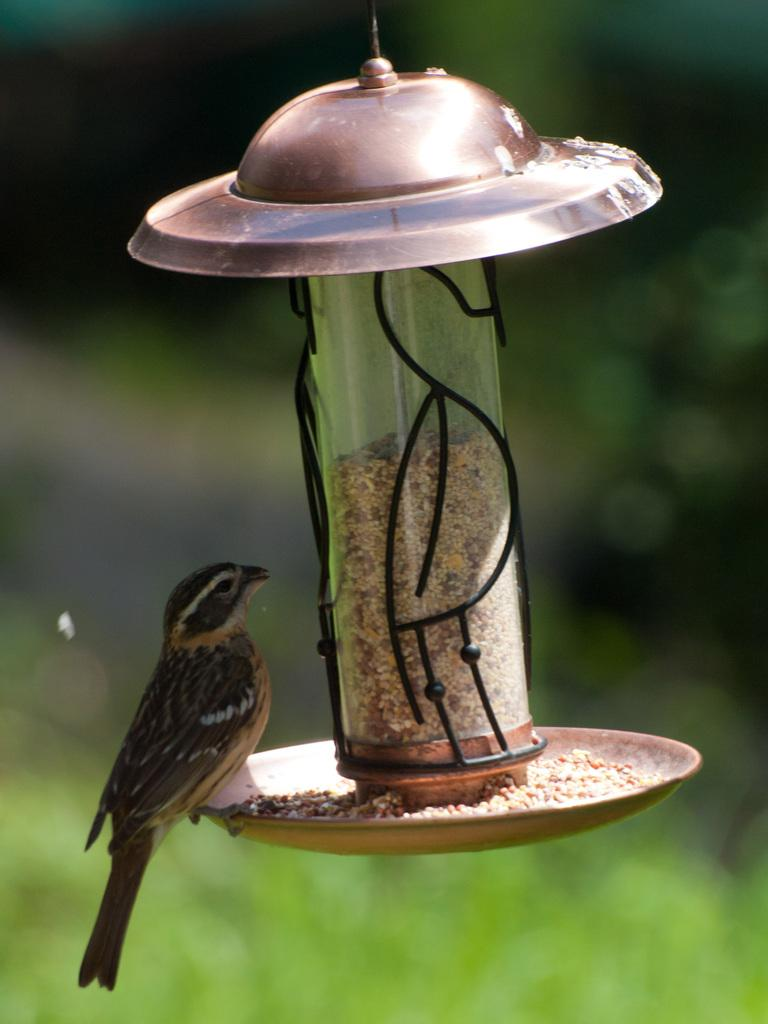What type of animal is present in the image? There is a bird in the image. Can you describe the background of the image? The background of the image is blurry. Where is the key located in the image? There is no key present in the image. Is the bird drinking from a stream in the image? There is no stream present in the image. What type of muscle can be seen in the image? There are no muscles visible in the image; it features a bird and a blurry background. 